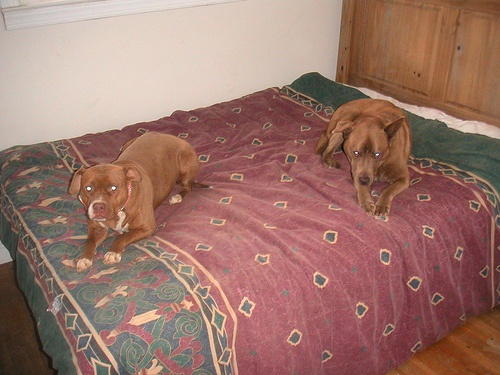Describe the objects in this image and their specific colors. I can see bed in darkgray, brown, gray, maroon, and salmon tones, dog in darkgray, brown, and tan tones, and dog in darkgray, brown, and maroon tones in this image. 